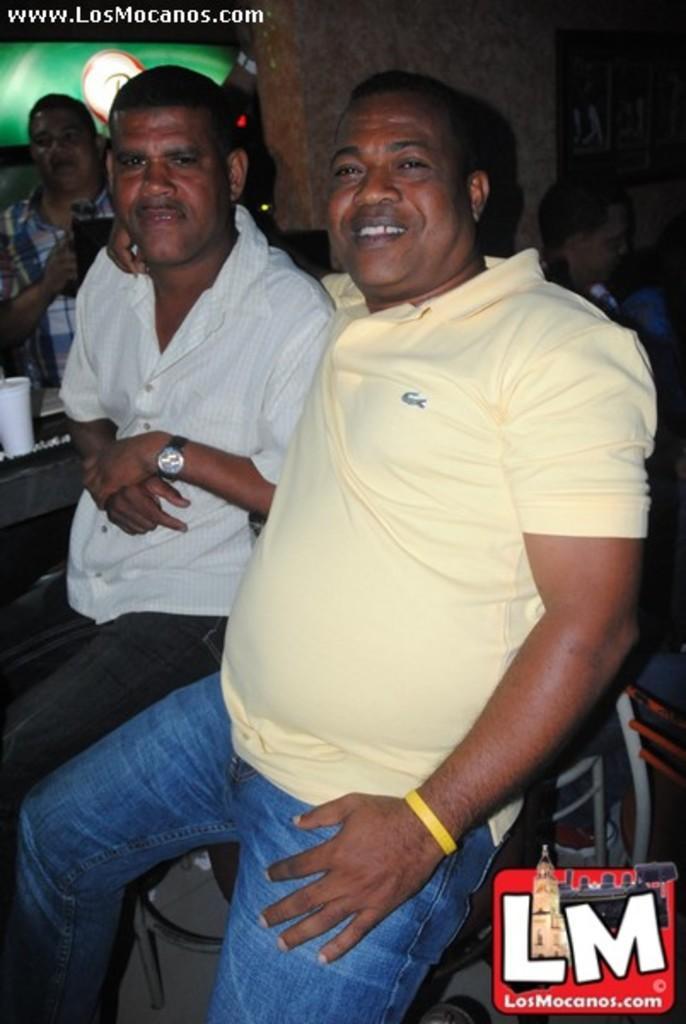Could you give a brief overview of what you see in this image? This picture shows four people as first person is standing,second person is seated on the chair,third person is seated with a smile on his face fourth one is also seated. 